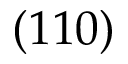Convert formula to latex. <formula><loc_0><loc_0><loc_500><loc_500>( 1 1 0 )</formula> 